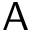Convert formula to latex. <formula><loc_0><loc_0><loc_500><loc_500>A</formula> 